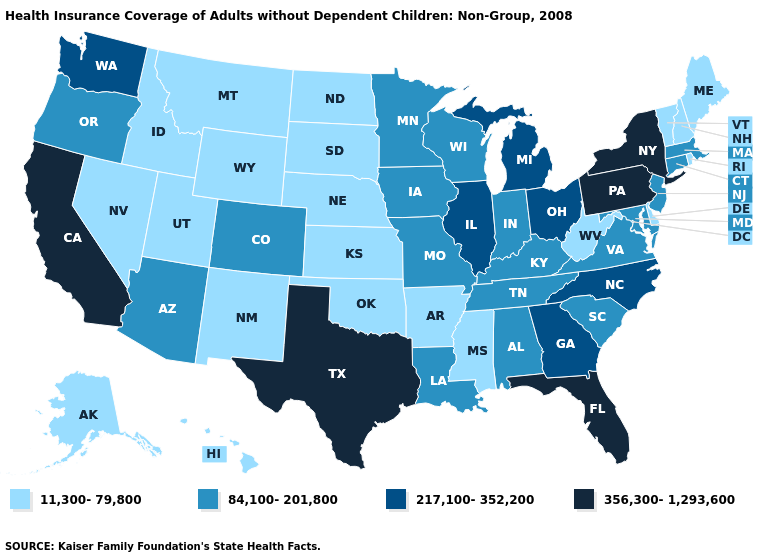Does Illinois have the highest value in the MidWest?
Give a very brief answer. Yes. Does Montana have the lowest value in the West?
Keep it brief. Yes. What is the value of Kansas?
Short answer required. 11,300-79,800. Which states have the lowest value in the MidWest?
Give a very brief answer. Kansas, Nebraska, North Dakota, South Dakota. Name the states that have a value in the range 356,300-1,293,600?
Give a very brief answer. California, Florida, New York, Pennsylvania, Texas. Name the states that have a value in the range 84,100-201,800?
Short answer required. Alabama, Arizona, Colorado, Connecticut, Indiana, Iowa, Kentucky, Louisiana, Maryland, Massachusetts, Minnesota, Missouri, New Jersey, Oregon, South Carolina, Tennessee, Virginia, Wisconsin. What is the lowest value in states that border New Hampshire?
Write a very short answer. 11,300-79,800. What is the value of Alabama?
Be succinct. 84,100-201,800. What is the lowest value in the USA?
Concise answer only. 11,300-79,800. Which states have the lowest value in the USA?
Be succinct. Alaska, Arkansas, Delaware, Hawaii, Idaho, Kansas, Maine, Mississippi, Montana, Nebraska, Nevada, New Hampshire, New Mexico, North Dakota, Oklahoma, Rhode Island, South Dakota, Utah, Vermont, West Virginia, Wyoming. Which states have the lowest value in the West?
Short answer required. Alaska, Hawaii, Idaho, Montana, Nevada, New Mexico, Utah, Wyoming. What is the value of Florida?
Answer briefly. 356,300-1,293,600. What is the value of Kansas?
Keep it brief. 11,300-79,800. What is the highest value in the West ?
Concise answer only. 356,300-1,293,600. What is the value of Indiana?
Write a very short answer. 84,100-201,800. 